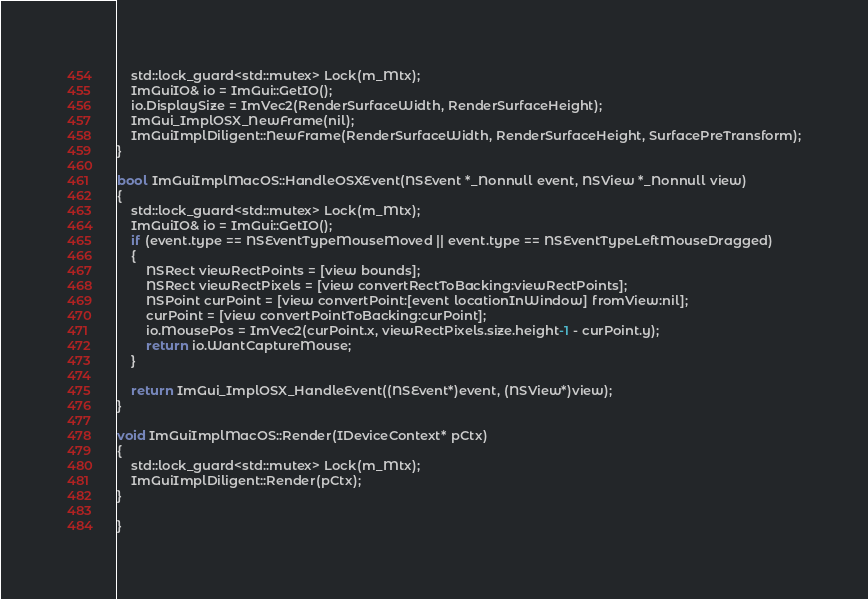<code> <loc_0><loc_0><loc_500><loc_500><_ObjectiveC_>    std::lock_guard<std::mutex> Lock(m_Mtx);
    ImGuiIO& io = ImGui::GetIO();
    io.DisplaySize = ImVec2(RenderSurfaceWidth, RenderSurfaceHeight);
    ImGui_ImplOSX_NewFrame(nil);
    ImGuiImplDiligent::NewFrame(RenderSurfaceWidth, RenderSurfaceHeight, SurfacePreTransform);
}

bool ImGuiImplMacOS::HandleOSXEvent(NSEvent *_Nonnull event, NSView *_Nonnull view)
{
    std::lock_guard<std::mutex> Lock(m_Mtx);
    ImGuiIO& io = ImGui::GetIO();
    if (event.type == NSEventTypeMouseMoved || event.type == NSEventTypeLeftMouseDragged)
    {
        NSRect viewRectPoints = [view bounds];
        NSRect viewRectPixels = [view convertRectToBacking:viewRectPoints];
        NSPoint curPoint = [view convertPoint:[event locationInWindow] fromView:nil];
        curPoint = [view convertPointToBacking:curPoint];
        io.MousePos = ImVec2(curPoint.x, viewRectPixels.size.height-1 - curPoint.y);
        return io.WantCaptureMouse;
    }

    return ImGui_ImplOSX_HandleEvent((NSEvent*)event, (NSView*)view);
}

void ImGuiImplMacOS::Render(IDeviceContext* pCtx)
{
    std::lock_guard<std::mutex> Lock(m_Mtx);
    ImGuiImplDiligent::Render(pCtx);
}

}
</code> 